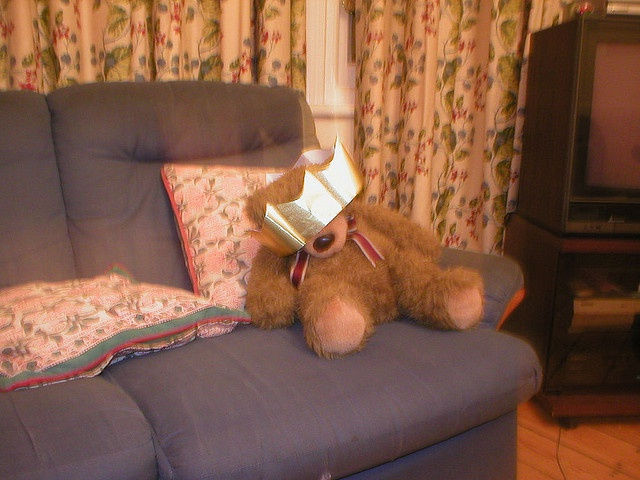Describe the objects in this image and their specific colors. I can see couch in brown, gray, maroon, and tan tones, teddy bear in brown, maroon, and white tones, and tv in brown, black, and maroon tones in this image. 